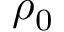Convert formula to latex. <formula><loc_0><loc_0><loc_500><loc_500>\rho _ { 0 }</formula> 